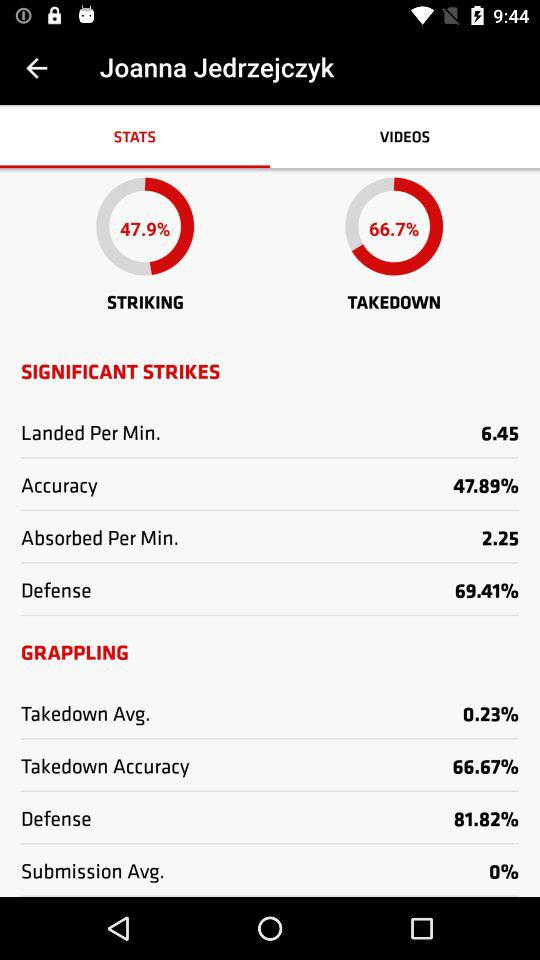Which tab is selected? The selected tab is "STATS". 